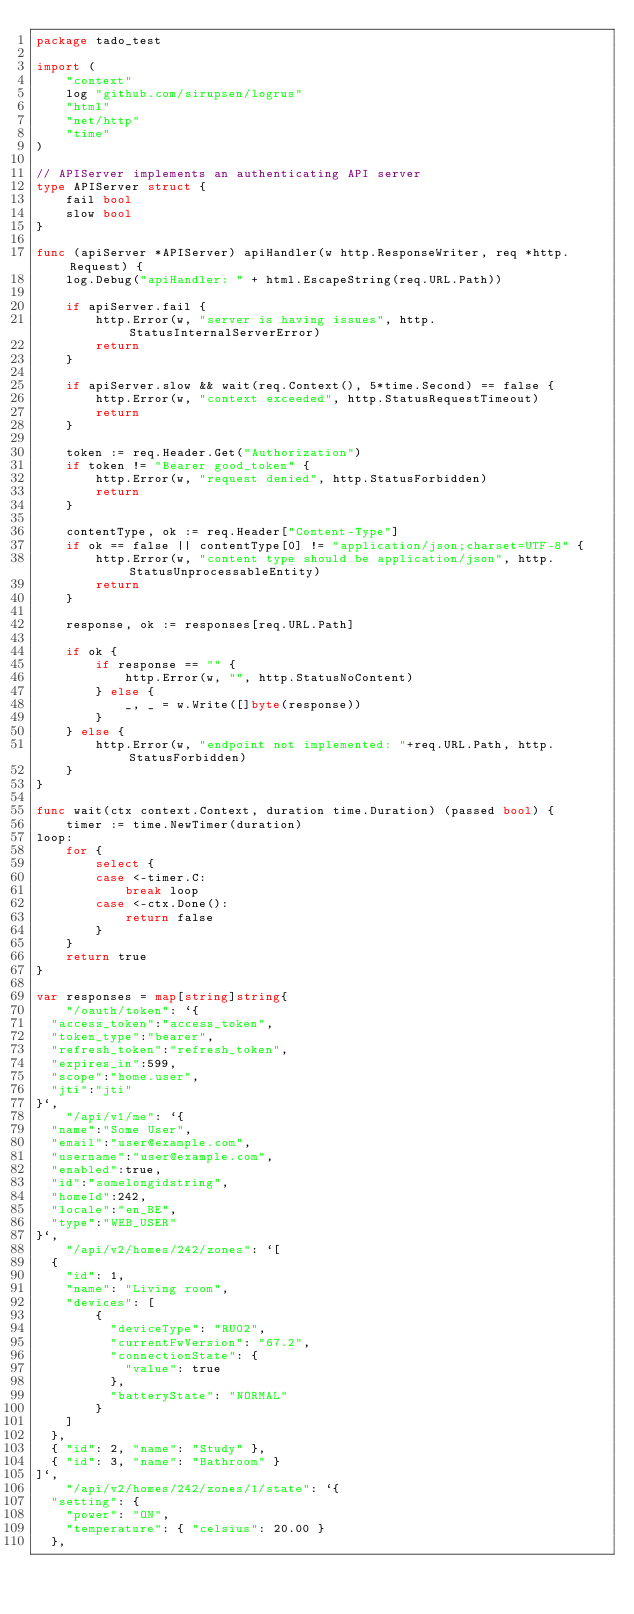Convert code to text. <code><loc_0><loc_0><loc_500><loc_500><_Go_>package tado_test

import (
	"context"
	log "github.com/sirupsen/logrus"
	"html"
	"net/http"
	"time"
)

// APIServer implements an authenticating API server
type APIServer struct {
	fail bool
	slow bool
}

func (apiServer *APIServer) apiHandler(w http.ResponseWriter, req *http.Request) {
	log.Debug("apiHandler: " + html.EscapeString(req.URL.Path))

	if apiServer.fail {
		http.Error(w, "server is having issues", http.StatusInternalServerError)
		return
	}

	if apiServer.slow && wait(req.Context(), 5*time.Second) == false {
		http.Error(w, "context exceeded", http.StatusRequestTimeout)
		return
	}

	token := req.Header.Get("Authorization")
	if token != "Bearer good_token" {
		http.Error(w, "request denied", http.StatusForbidden)
		return
	}

	contentType, ok := req.Header["Content-Type"]
	if ok == false || contentType[0] != "application/json;charset=UTF-8" {
		http.Error(w, "content type should be application/json", http.StatusUnprocessableEntity)
		return
	}

	response, ok := responses[req.URL.Path]

	if ok {
		if response == "" {
			http.Error(w, "", http.StatusNoContent)
		} else {
			_, _ = w.Write([]byte(response))
		}
	} else {
		http.Error(w, "endpoint not implemented: "+req.URL.Path, http.StatusForbidden)
	}
}

func wait(ctx context.Context, duration time.Duration) (passed bool) {
	timer := time.NewTimer(duration)
loop:
	for {
		select {
		case <-timer.C:
			break loop
		case <-ctx.Done():
			return false
		}
	}
	return true
}

var responses = map[string]string{
	"/oauth/token": `{
  "access_token":"access_token",
  "token_type":"bearer",
  "refresh_token":"refresh_token",
  "expires_in":599,
  "scope":"home.user",
  "jti":"jti"
}`,
	"/api/v1/me": `{
  "name":"Some User",
  "email":"user@example.com",
  "username":"user@example.com",
  "enabled":true,
  "id":"somelongidstring",
  "homeId":242,
  "locale":"en_BE",
  "type":"WEB_USER"
}`,
	"/api/v2/homes/242/zones": `[
  { 
    "id": 1, 
    "name": "Living room", 
    "devices": [ 
		{
		  "deviceType": "RU02",
		  "currentFwVersion": "67.2", 
		  "connectionState": { 
			"value": true 
		  }, 
		  "batteryState": "NORMAL" 
		}
    ]
  },
  { "id": 2, "name": "Study" },
  { "id": 3, "name": "Bathroom" }
]`,
	"/api/v2/homes/242/zones/1/state": `{
  "setting": {
    "power": "ON",
    "temperature": { "celsius": 20.00 }
  },</code> 